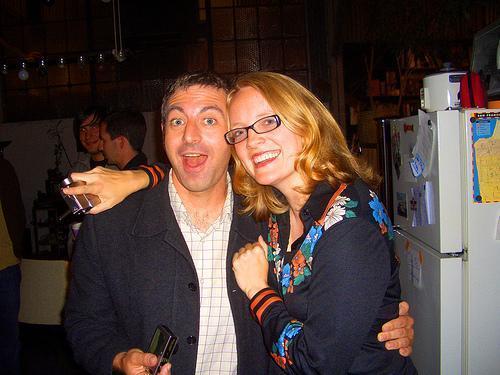How many people are in the couple?
Give a very brief answer. 2. How many people can you see?
Give a very brief answer. 4. How many airplanes do you see?
Give a very brief answer. 0. 